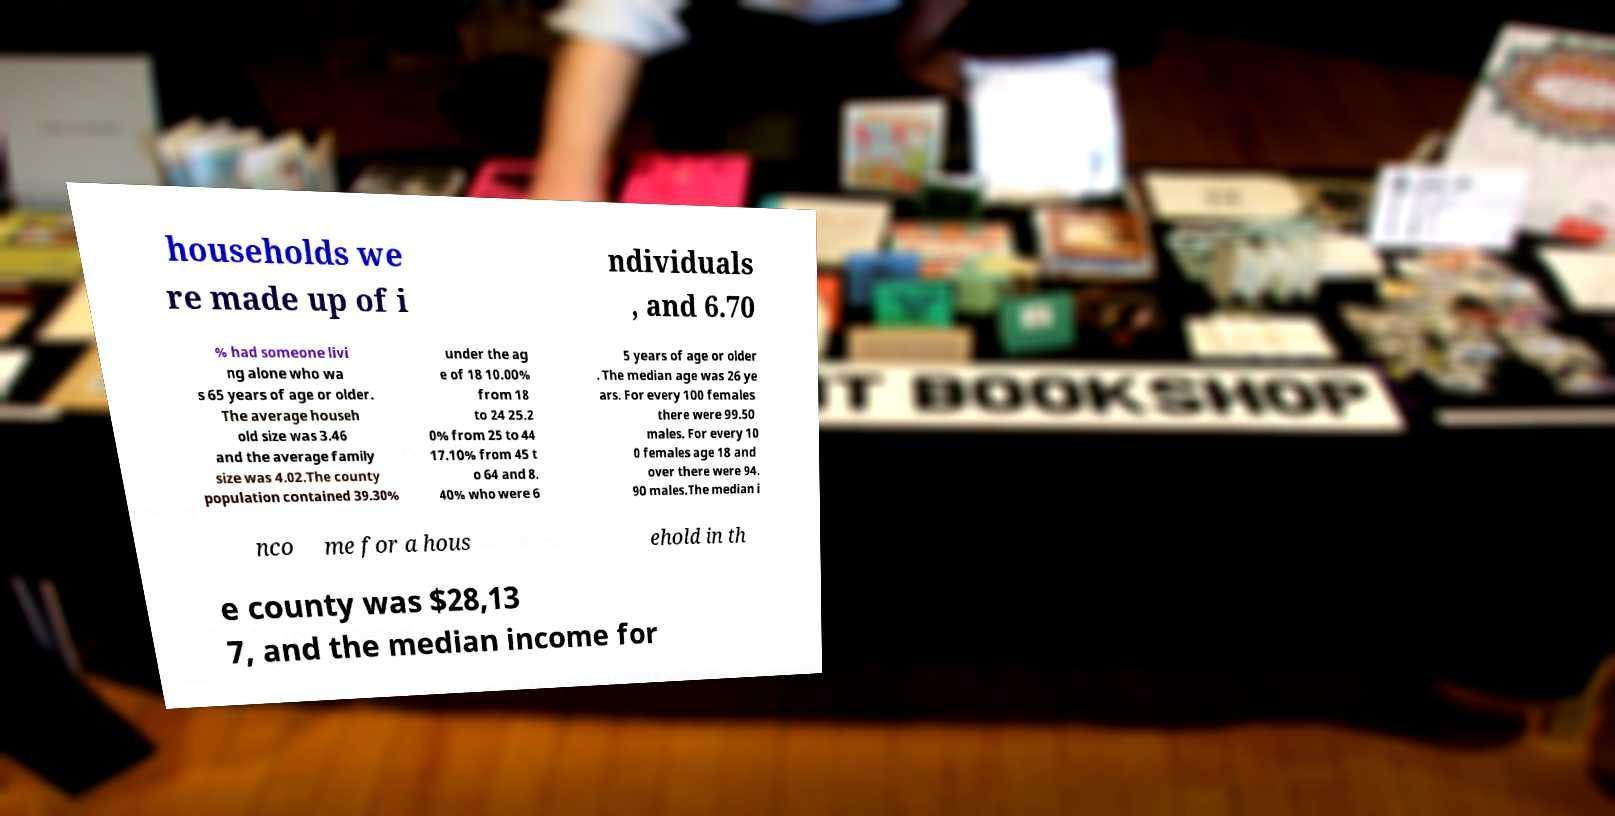Can you read and provide the text displayed in the image?This photo seems to have some interesting text. Can you extract and type it out for me? households we re made up of i ndividuals , and 6.70 % had someone livi ng alone who wa s 65 years of age or older. The average househ old size was 3.46 and the average family size was 4.02.The county population contained 39.30% under the ag e of 18 10.00% from 18 to 24 25.2 0% from 25 to 44 17.10% from 45 t o 64 and 8. 40% who were 6 5 years of age or older . The median age was 26 ye ars. For every 100 females there were 99.50 males. For every 10 0 females age 18 and over there were 94. 90 males.The median i nco me for a hous ehold in th e county was $28,13 7, and the median income for 